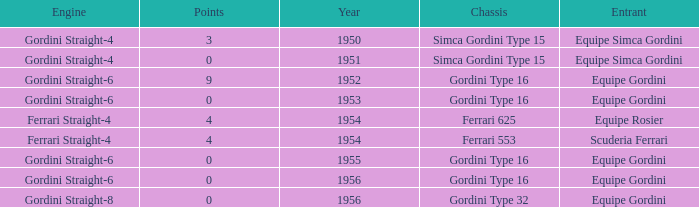Before 1956, what Chassis has Gordini Straight-4 engine with 3 points? Simca Gordini Type 15. 